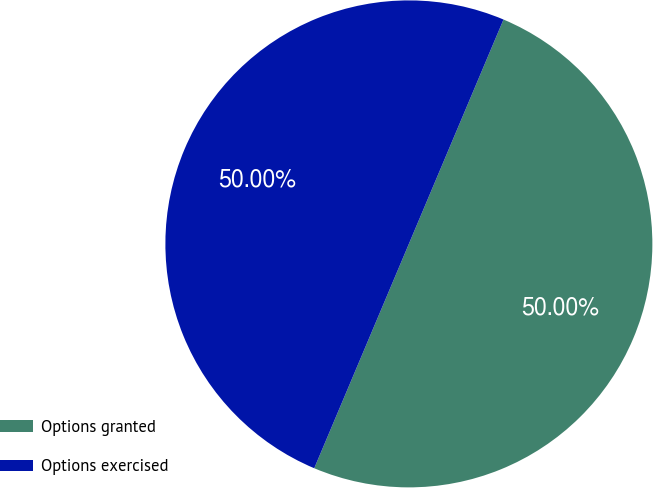<chart> <loc_0><loc_0><loc_500><loc_500><pie_chart><fcel>Options granted<fcel>Options exercised<nl><fcel>50.0%<fcel>50.0%<nl></chart> 